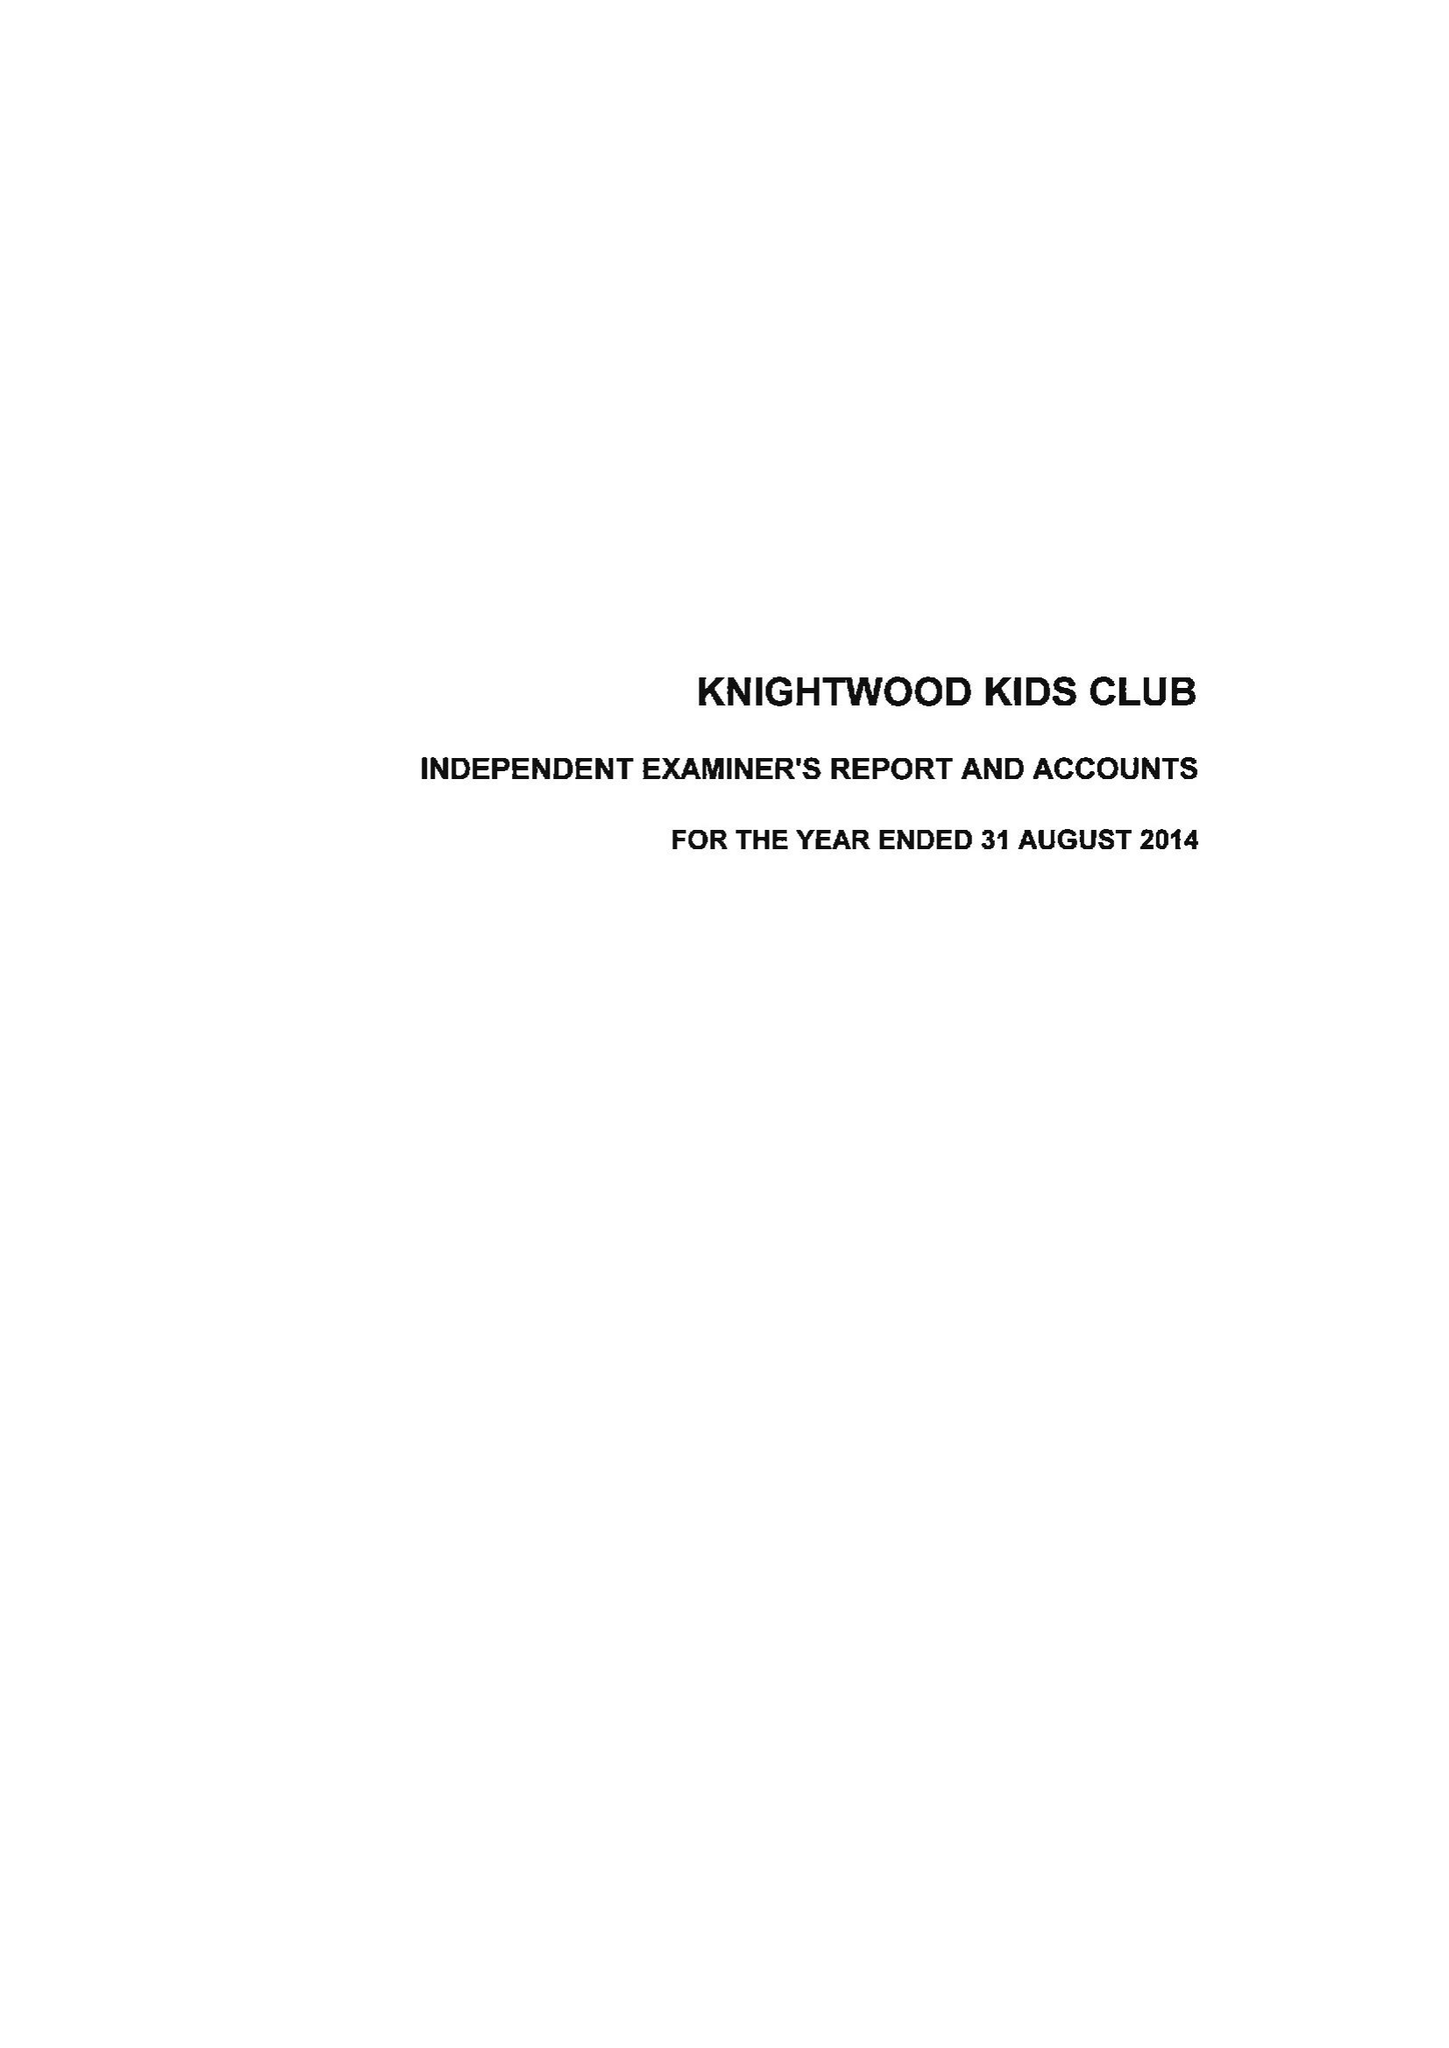What is the value for the spending_annually_in_british_pounds?
Answer the question using a single word or phrase. 71341.00 